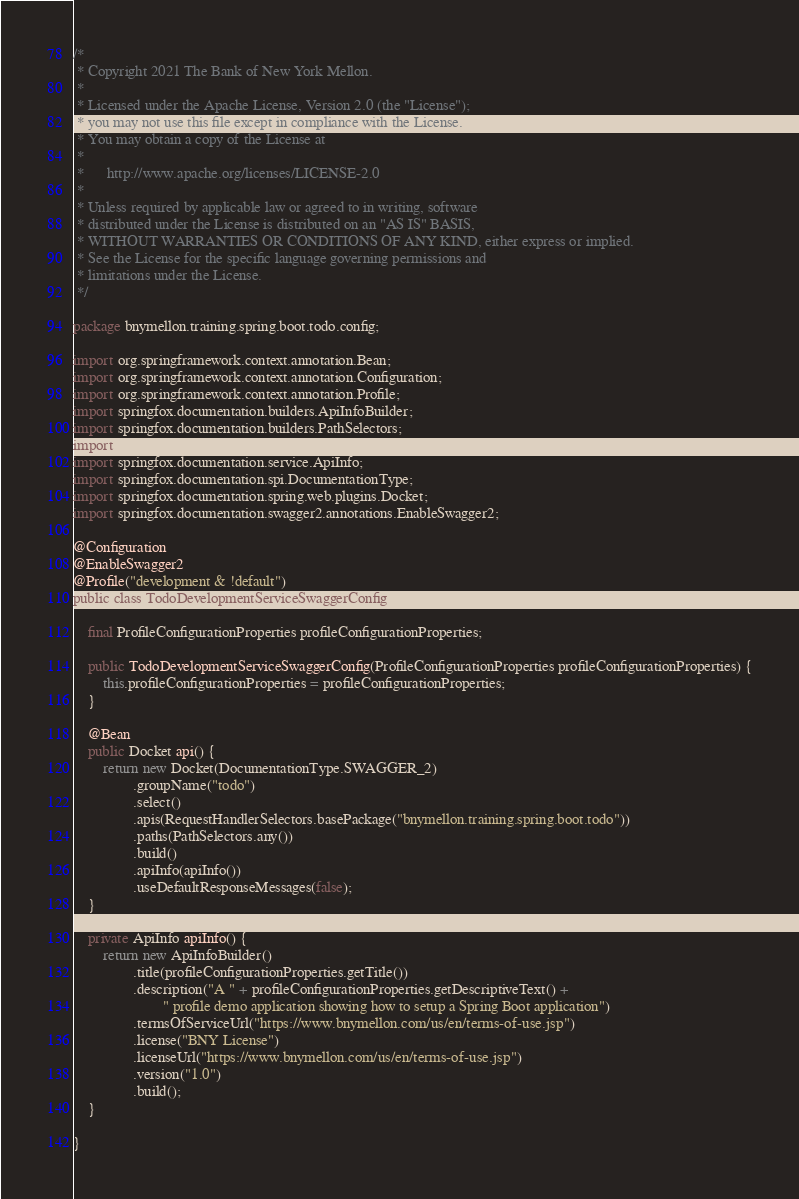Convert code to text. <code><loc_0><loc_0><loc_500><loc_500><_Java_>/*
 * Copyright 2021 The Bank of New York Mellon.
 *
 * Licensed under the Apache License, Version 2.0 (the "License");
 * you may not use this file except in compliance with the License.
 * You may obtain a copy of the License at
 *
 *      http://www.apache.org/licenses/LICENSE-2.0
 *
 * Unless required by applicable law or agreed to in writing, software
 * distributed under the License is distributed on an "AS IS" BASIS,
 * WITHOUT WARRANTIES OR CONDITIONS OF ANY KIND, either express or implied.
 * See the License for the specific language governing permissions and
 * limitations under the License.
 */

package bnymellon.training.spring.boot.todo.config;

import org.springframework.context.annotation.Bean;
import org.springframework.context.annotation.Configuration;
import org.springframework.context.annotation.Profile;
import springfox.documentation.builders.ApiInfoBuilder;
import springfox.documentation.builders.PathSelectors;
import springfox.documentation.builders.RequestHandlerSelectors;
import springfox.documentation.service.ApiInfo;
import springfox.documentation.spi.DocumentationType;
import springfox.documentation.spring.web.plugins.Docket;
import springfox.documentation.swagger2.annotations.EnableSwagger2;

@Configuration
@EnableSwagger2
@Profile("development & !default")
public class TodoDevelopmentServiceSwaggerConfig {

    final ProfileConfigurationProperties profileConfigurationProperties;

    public TodoDevelopmentServiceSwaggerConfig(ProfileConfigurationProperties profileConfigurationProperties) {
        this.profileConfigurationProperties = profileConfigurationProperties;
    }

    @Bean
    public Docket api() {
        return new Docket(DocumentationType.SWAGGER_2)
                .groupName("todo")
                .select()
                .apis(RequestHandlerSelectors.basePackage("bnymellon.training.spring.boot.todo"))
                .paths(PathSelectors.any())
                .build()
                .apiInfo(apiInfo())
                .useDefaultResponseMessages(false);
    }

    private ApiInfo apiInfo() {
        return new ApiInfoBuilder()
                .title(profileConfigurationProperties.getTitle())
                .description("A " + profileConfigurationProperties.getDescriptiveText() +
                        " profile demo application showing how to setup a Spring Boot application")
                .termsOfServiceUrl("https://www.bnymellon.com/us/en/terms-of-use.jsp")
                .license("BNY License")
                .licenseUrl("https://www.bnymellon.com/us/en/terms-of-use.jsp")
                .version("1.0")
                .build();
    }

}
</code> 